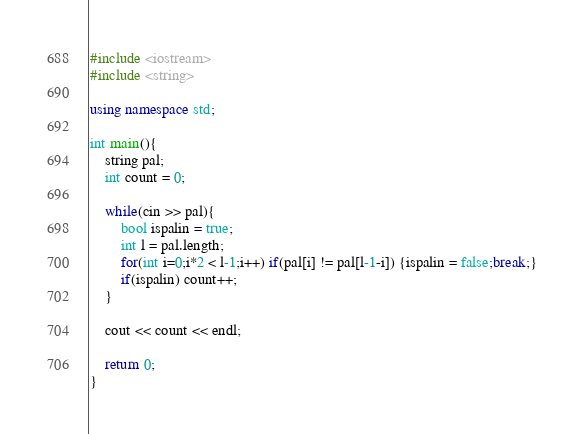Convert code to text. <code><loc_0><loc_0><loc_500><loc_500><_C++_>#include <iostream>
#include <string>

using namespace std;

int main(){
	string pal;
	int count = 0;
	
	while(cin >> pal){
		bool ispalin = true;
		int l = pal.length;		
		for(int i=0;i*2 < l-1;i++) if(pal[i] != pal[l-1-i]) {ispalin = false;break;}
		if(ispalin) count++;
	}
	
	cout << count << endl;
	
	return 0;
}</code> 